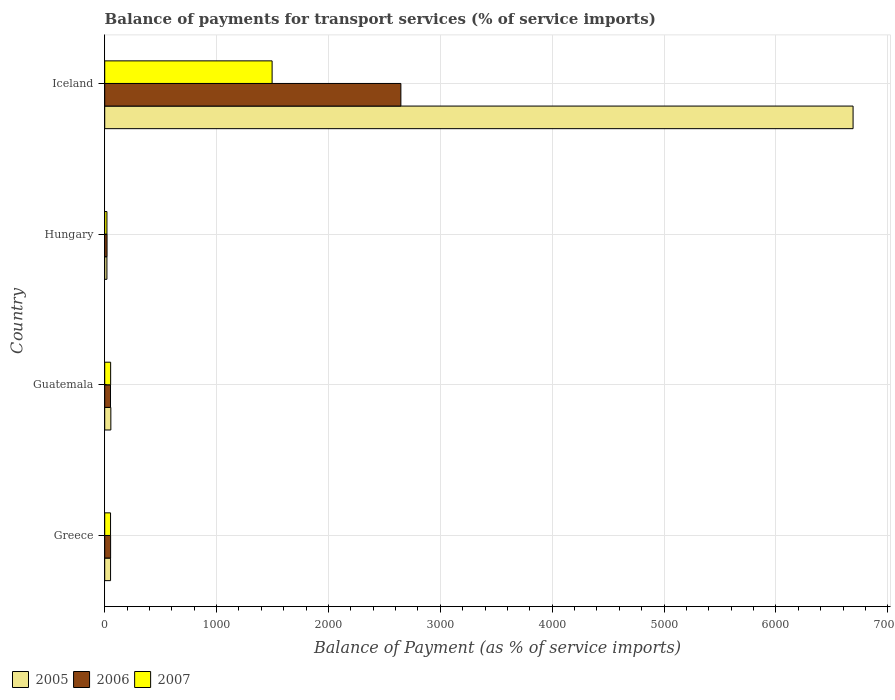Are the number of bars per tick equal to the number of legend labels?
Your answer should be very brief. Yes. Are the number of bars on each tick of the Y-axis equal?
Your response must be concise. Yes. How many bars are there on the 1st tick from the top?
Your answer should be very brief. 3. What is the label of the 1st group of bars from the top?
Offer a terse response. Iceland. In how many cases, is the number of bars for a given country not equal to the number of legend labels?
Make the answer very short. 0. What is the balance of payments for transport services in 2007 in Guatemala?
Keep it short and to the point. 53.01. Across all countries, what is the maximum balance of payments for transport services in 2006?
Give a very brief answer. 2647.13. Across all countries, what is the minimum balance of payments for transport services in 2005?
Offer a terse response. 19.64. In which country was the balance of payments for transport services in 2006 maximum?
Your answer should be compact. Iceland. In which country was the balance of payments for transport services in 2005 minimum?
Your answer should be very brief. Hungary. What is the total balance of payments for transport services in 2007 in the graph?
Make the answer very short. 1621.08. What is the difference between the balance of payments for transport services in 2007 in Guatemala and that in Hungary?
Your answer should be very brief. 33.24. What is the difference between the balance of payments for transport services in 2006 in Greece and the balance of payments for transport services in 2007 in Iceland?
Your answer should be compact. -1443.55. What is the average balance of payments for transport services in 2007 per country?
Provide a succinct answer. 405.27. What is the difference between the balance of payments for transport services in 2005 and balance of payments for transport services in 2006 in Guatemala?
Provide a short and direct response. 2.96. What is the ratio of the balance of payments for transport services in 2005 in Greece to that in Iceland?
Give a very brief answer. 0.01. What is the difference between the highest and the second highest balance of payments for transport services in 2007?
Offer a terse response. 1443.21. What is the difference between the highest and the lowest balance of payments for transport services in 2005?
Your response must be concise. 6669.52. In how many countries, is the balance of payments for transport services in 2006 greater than the average balance of payments for transport services in 2006 taken over all countries?
Your answer should be compact. 1. What does the 2nd bar from the bottom in Guatemala represents?
Offer a very short reply. 2006. How many countries are there in the graph?
Offer a very short reply. 4. What is the difference between two consecutive major ticks on the X-axis?
Your answer should be compact. 1000. Does the graph contain grids?
Your response must be concise. Yes. How many legend labels are there?
Provide a short and direct response. 3. How are the legend labels stacked?
Make the answer very short. Horizontal. What is the title of the graph?
Offer a very short reply. Balance of payments for transport services (% of service imports). Does "1989" appear as one of the legend labels in the graph?
Give a very brief answer. No. What is the label or title of the X-axis?
Give a very brief answer. Balance of Payment (as % of service imports). What is the Balance of Payment (as % of service imports) of 2005 in Greece?
Offer a very short reply. 52.24. What is the Balance of Payment (as % of service imports) in 2006 in Greece?
Offer a terse response. 52.67. What is the Balance of Payment (as % of service imports) in 2007 in Greece?
Your answer should be compact. 52.08. What is the Balance of Payment (as % of service imports) in 2005 in Guatemala?
Provide a short and direct response. 54.72. What is the Balance of Payment (as % of service imports) of 2006 in Guatemala?
Give a very brief answer. 51.76. What is the Balance of Payment (as % of service imports) of 2007 in Guatemala?
Provide a succinct answer. 53.01. What is the Balance of Payment (as % of service imports) in 2005 in Hungary?
Your answer should be compact. 19.64. What is the Balance of Payment (as % of service imports) of 2006 in Hungary?
Offer a terse response. 20.81. What is the Balance of Payment (as % of service imports) of 2007 in Hungary?
Your response must be concise. 19.77. What is the Balance of Payment (as % of service imports) of 2005 in Iceland?
Provide a short and direct response. 6689.16. What is the Balance of Payment (as % of service imports) of 2006 in Iceland?
Provide a succinct answer. 2647.13. What is the Balance of Payment (as % of service imports) of 2007 in Iceland?
Provide a succinct answer. 1496.22. Across all countries, what is the maximum Balance of Payment (as % of service imports) of 2005?
Offer a very short reply. 6689.16. Across all countries, what is the maximum Balance of Payment (as % of service imports) of 2006?
Provide a succinct answer. 2647.13. Across all countries, what is the maximum Balance of Payment (as % of service imports) in 2007?
Ensure brevity in your answer.  1496.22. Across all countries, what is the minimum Balance of Payment (as % of service imports) of 2005?
Keep it short and to the point. 19.64. Across all countries, what is the minimum Balance of Payment (as % of service imports) in 2006?
Ensure brevity in your answer.  20.81. Across all countries, what is the minimum Balance of Payment (as % of service imports) in 2007?
Give a very brief answer. 19.77. What is the total Balance of Payment (as % of service imports) of 2005 in the graph?
Offer a terse response. 6815.75. What is the total Balance of Payment (as % of service imports) in 2006 in the graph?
Offer a very short reply. 2772.37. What is the total Balance of Payment (as % of service imports) in 2007 in the graph?
Your answer should be compact. 1621.08. What is the difference between the Balance of Payment (as % of service imports) of 2005 in Greece and that in Guatemala?
Offer a terse response. -2.48. What is the difference between the Balance of Payment (as % of service imports) of 2006 in Greece and that in Guatemala?
Give a very brief answer. 0.91. What is the difference between the Balance of Payment (as % of service imports) of 2007 in Greece and that in Guatemala?
Your answer should be very brief. -0.93. What is the difference between the Balance of Payment (as % of service imports) of 2005 in Greece and that in Hungary?
Keep it short and to the point. 32.6. What is the difference between the Balance of Payment (as % of service imports) in 2006 in Greece and that in Hungary?
Make the answer very short. 31.86. What is the difference between the Balance of Payment (as % of service imports) in 2007 in Greece and that in Hungary?
Ensure brevity in your answer.  32.31. What is the difference between the Balance of Payment (as % of service imports) of 2005 in Greece and that in Iceland?
Make the answer very short. -6636.92. What is the difference between the Balance of Payment (as % of service imports) in 2006 in Greece and that in Iceland?
Provide a succinct answer. -2594.45. What is the difference between the Balance of Payment (as % of service imports) in 2007 in Greece and that in Iceland?
Provide a short and direct response. -1444.14. What is the difference between the Balance of Payment (as % of service imports) in 2005 in Guatemala and that in Hungary?
Offer a very short reply. 35.08. What is the difference between the Balance of Payment (as % of service imports) of 2006 in Guatemala and that in Hungary?
Give a very brief answer. 30.95. What is the difference between the Balance of Payment (as % of service imports) of 2007 in Guatemala and that in Hungary?
Offer a very short reply. 33.24. What is the difference between the Balance of Payment (as % of service imports) of 2005 in Guatemala and that in Iceland?
Your answer should be compact. -6634.44. What is the difference between the Balance of Payment (as % of service imports) in 2006 in Guatemala and that in Iceland?
Provide a succinct answer. -2595.37. What is the difference between the Balance of Payment (as % of service imports) of 2007 in Guatemala and that in Iceland?
Make the answer very short. -1443.21. What is the difference between the Balance of Payment (as % of service imports) of 2005 in Hungary and that in Iceland?
Your answer should be very brief. -6669.52. What is the difference between the Balance of Payment (as % of service imports) of 2006 in Hungary and that in Iceland?
Offer a very short reply. -2626.32. What is the difference between the Balance of Payment (as % of service imports) in 2007 in Hungary and that in Iceland?
Ensure brevity in your answer.  -1476.45. What is the difference between the Balance of Payment (as % of service imports) of 2005 in Greece and the Balance of Payment (as % of service imports) of 2006 in Guatemala?
Provide a succinct answer. 0.48. What is the difference between the Balance of Payment (as % of service imports) in 2005 in Greece and the Balance of Payment (as % of service imports) in 2007 in Guatemala?
Your answer should be compact. -0.77. What is the difference between the Balance of Payment (as % of service imports) of 2006 in Greece and the Balance of Payment (as % of service imports) of 2007 in Guatemala?
Provide a short and direct response. -0.33. What is the difference between the Balance of Payment (as % of service imports) in 2005 in Greece and the Balance of Payment (as % of service imports) in 2006 in Hungary?
Ensure brevity in your answer.  31.42. What is the difference between the Balance of Payment (as % of service imports) in 2005 in Greece and the Balance of Payment (as % of service imports) in 2007 in Hungary?
Offer a very short reply. 32.46. What is the difference between the Balance of Payment (as % of service imports) in 2006 in Greece and the Balance of Payment (as % of service imports) in 2007 in Hungary?
Provide a succinct answer. 32.9. What is the difference between the Balance of Payment (as % of service imports) of 2005 in Greece and the Balance of Payment (as % of service imports) of 2006 in Iceland?
Offer a terse response. -2594.89. What is the difference between the Balance of Payment (as % of service imports) of 2005 in Greece and the Balance of Payment (as % of service imports) of 2007 in Iceland?
Your response must be concise. -1443.99. What is the difference between the Balance of Payment (as % of service imports) of 2006 in Greece and the Balance of Payment (as % of service imports) of 2007 in Iceland?
Ensure brevity in your answer.  -1443.55. What is the difference between the Balance of Payment (as % of service imports) in 2005 in Guatemala and the Balance of Payment (as % of service imports) in 2006 in Hungary?
Ensure brevity in your answer.  33.91. What is the difference between the Balance of Payment (as % of service imports) in 2005 in Guatemala and the Balance of Payment (as % of service imports) in 2007 in Hungary?
Your answer should be very brief. 34.95. What is the difference between the Balance of Payment (as % of service imports) in 2006 in Guatemala and the Balance of Payment (as % of service imports) in 2007 in Hungary?
Make the answer very short. 31.99. What is the difference between the Balance of Payment (as % of service imports) in 2005 in Guatemala and the Balance of Payment (as % of service imports) in 2006 in Iceland?
Your answer should be very brief. -2592.41. What is the difference between the Balance of Payment (as % of service imports) of 2005 in Guatemala and the Balance of Payment (as % of service imports) of 2007 in Iceland?
Provide a short and direct response. -1441.5. What is the difference between the Balance of Payment (as % of service imports) in 2006 in Guatemala and the Balance of Payment (as % of service imports) in 2007 in Iceland?
Your answer should be very brief. -1444.46. What is the difference between the Balance of Payment (as % of service imports) of 2005 in Hungary and the Balance of Payment (as % of service imports) of 2006 in Iceland?
Ensure brevity in your answer.  -2627.49. What is the difference between the Balance of Payment (as % of service imports) in 2005 in Hungary and the Balance of Payment (as % of service imports) in 2007 in Iceland?
Ensure brevity in your answer.  -1476.58. What is the difference between the Balance of Payment (as % of service imports) of 2006 in Hungary and the Balance of Payment (as % of service imports) of 2007 in Iceland?
Keep it short and to the point. -1475.41. What is the average Balance of Payment (as % of service imports) in 2005 per country?
Give a very brief answer. 1703.94. What is the average Balance of Payment (as % of service imports) in 2006 per country?
Offer a terse response. 693.09. What is the average Balance of Payment (as % of service imports) of 2007 per country?
Offer a very short reply. 405.27. What is the difference between the Balance of Payment (as % of service imports) in 2005 and Balance of Payment (as % of service imports) in 2006 in Greece?
Provide a short and direct response. -0.44. What is the difference between the Balance of Payment (as % of service imports) in 2005 and Balance of Payment (as % of service imports) in 2007 in Greece?
Your response must be concise. 0.16. What is the difference between the Balance of Payment (as % of service imports) in 2006 and Balance of Payment (as % of service imports) in 2007 in Greece?
Ensure brevity in your answer.  0.59. What is the difference between the Balance of Payment (as % of service imports) of 2005 and Balance of Payment (as % of service imports) of 2006 in Guatemala?
Offer a terse response. 2.96. What is the difference between the Balance of Payment (as % of service imports) in 2005 and Balance of Payment (as % of service imports) in 2007 in Guatemala?
Provide a short and direct response. 1.71. What is the difference between the Balance of Payment (as % of service imports) in 2006 and Balance of Payment (as % of service imports) in 2007 in Guatemala?
Provide a succinct answer. -1.25. What is the difference between the Balance of Payment (as % of service imports) of 2005 and Balance of Payment (as % of service imports) of 2006 in Hungary?
Offer a very short reply. -1.17. What is the difference between the Balance of Payment (as % of service imports) of 2005 and Balance of Payment (as % of service imports) of 2007 in Hungary?
Your answer should be compact. -0.13. What is the difference between the Balance of Payment (as % of service imports) of 2006 and Balance of Payment (as % of service imports) of 2007 in Hungary?
Your answer should be compact. 1.04. What is the difference between the Balance of Payment (as % of service imports) in 2005 and Balance of Payment (as % of service imports) in 2006 in Iceland?
Make the answer very short. 4042.03. What is the difference between the Balance of Payment (as % of service imports) of 2005 and Balance of Payment (as % of service imports) of 2007 in Iceland?
Offer a very short reply. 5192.93. What is the difference between the Balance of Payment (as % of service imports) of 2006 and Balance of Payment (as % of service imports) of 2007 in Iceland?
Make the answer very short. 1150.91. What is the ratio of the Balance of Payment (as % of service imports) in 2005 in Greece to that in Guatemala?
Provide a short and direct response. 0.95. What is the ratio of the Balance of Payment (as % of service imports) in 2006 in Greece to that in Guatemala?
Your response must be concise. 1.02. What is the ratio of the Balance of Payment (as % of service imports) in 2007 in Greece to that in Guatemala?
Ensure brevity in your answer.  0.98. What is the ratio of the Balance of Payment (as % of service imports) in 2005 in Greece to that in Hungary?
Offer a very short reply. 2.66. What is the ratio of the Balance of Payment (as % of service imports) of 2006 in Greece to that in Hungary?
Provide a short and direct response. 2.53. What is the ratio of the Balance of Payment (as % of service imports) in 2007 in Greece to that in Hungary?
Provide a short and direct response. 2.63. What is the ratio of the Balance of Payment (as % of service imports) in 2005 in Greece to that in Iceland?
Offer a terse response. 0.01. What is the ratio of the Balance of Payment (as % of service imports) of 2006 in Greece to that in Iceland?
Keep it short and to the point. 0.02. What is the ratio of the Balance of Payment (as % of service imports) in 2007 in Greece to that in Iceland?
Provide a succinct answer. 0.03. What is the ratio of the Balance of Payment (as % of service imports) in 2005 in Guatemala to that in Hungary?
Your answer should be compact. 2.79. What is the ratio of the Balance of Payment (as % of service imports) of 2006 in Guatemala to that in Hungary?
Offer a terse response. 2.49. What is the ratio of the Balance of Payment (as % of service imports) of 2007 in Guatemala to that in Hungary?
Make the answer very short. 2.68. What is the ratio of the Balance of Payment (as % of service imports) of 2005 in Guatemala to that in Iceland?
Keep it short and to the point. 0.01. What is the ratio of the Balance of Payment (as % of service imports) in 2006 in Guatemala to that in Iceland?
Offer a terse response. 0.02. What is the ratio of the Balance of Payment (as % of service imports) of 2007 in Guatemala to that in Iceland?
Offer a very short reply. 0.04. What is the ratio of the Balance of Payment (as % of service imports) of 2005 in Hungary to that in Iceland?
Give a very brief answer. 0. What is the ratio of the Balance of Payment (as % of service imports) of 2006 in Hungary to that in Iceland?
Ensure brevity in your answer.  0.01. What is the ratio of the Balance of Payment (as % of service imports) in 2007 in Hungary to that in Iceland?
Give a very brief answer. 0.01. What is the difference between the highest and the second highest Balance of Payment (as % of service imports) of 2005?
Your response must be concise. 6634.44. What is the difference between the highest and the second highest Balance of Payment (as % of service imports) of 2006?
Provide a short and direct response. 2594.45. What is the difference between the highest and the second highest Balance of Payment (as % of service imports) of 2007?
Your answer should be very brief. 1443.21. What is the difference between the highest and the lowest Balance of Payment (as % of service imports) in 2005?
Keep it short and to the point. 6669.52. What is the difference between the highest and the lowest Balance of Payment (as % of service imports) in 2006?
Your answer should be compact. 2626.32. What is the difference between the highest and the lowest Balance of Payment (as % of service imports) in 2007?
Ensure brevity in your answer.  1476.45. 